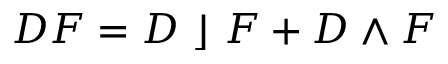Convert formula to latex. <formula><loc_0><loc_0><loc_500><loc_500>D F = D \rfloor F + D \wedge F</formula> 